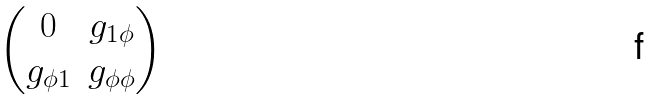<formula> <loc_0><loc_0><loc_500><loc_500>\begin{pmatrix} 0 & g _ { 1 \phi } \\ g _ { \phi 1 } & g _ { \phi \phi } \end{pmatrix}</formula> 